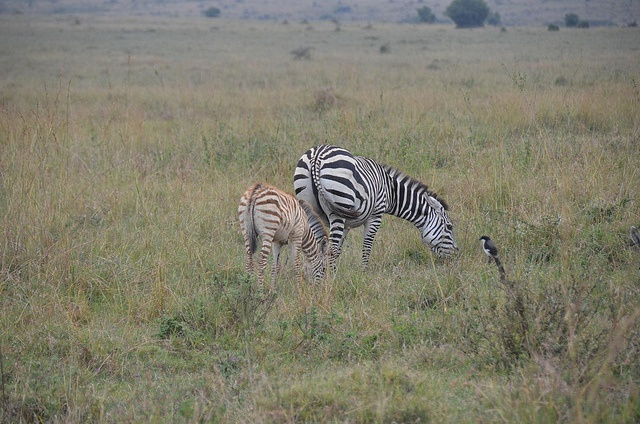Describe the objects in this image and their specific colors. I can see zebra in gray, darkgray, black, and lightgray tones, zebra in gray and darkgray tones, and bird in gray, black, and darkgray tones in this image. 